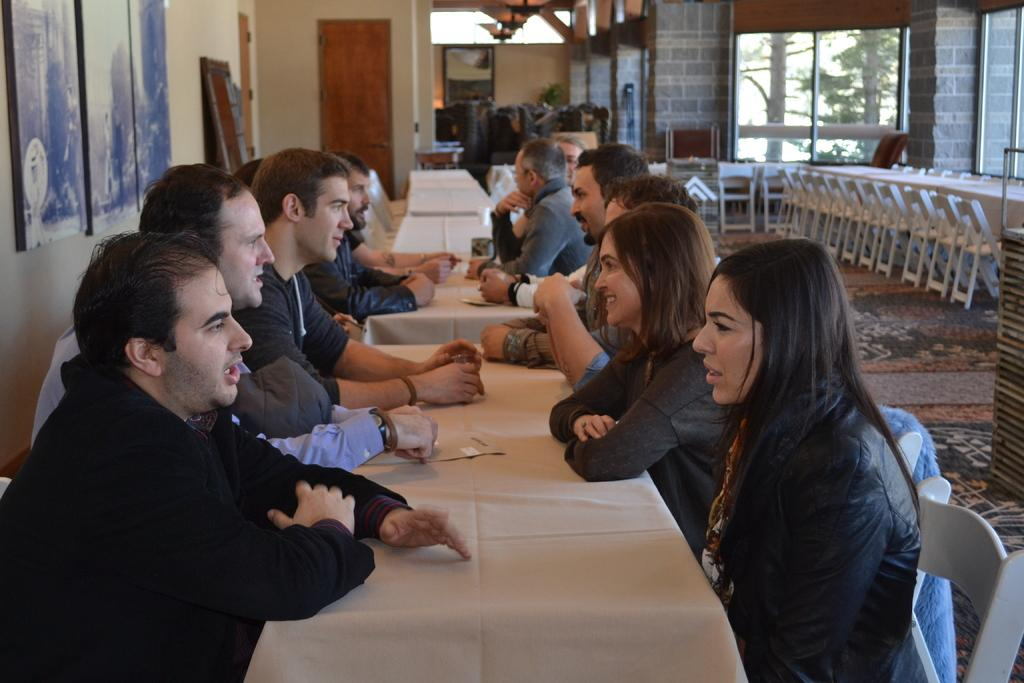What are the people in the image doing? The people in the image are sitting near a table. What can be seen on the wall in the image? There are photo frames on the wall in the image. What is visible in the background of the image? There are glass windows in the background of the image. What type of cable can be seen connecting the people in the image? There is no cable connecting the people in the image. What kind of attack is being carried out by the people in the image? There is no attack being carried out by the people in the image; they are simply sitting near a table. 